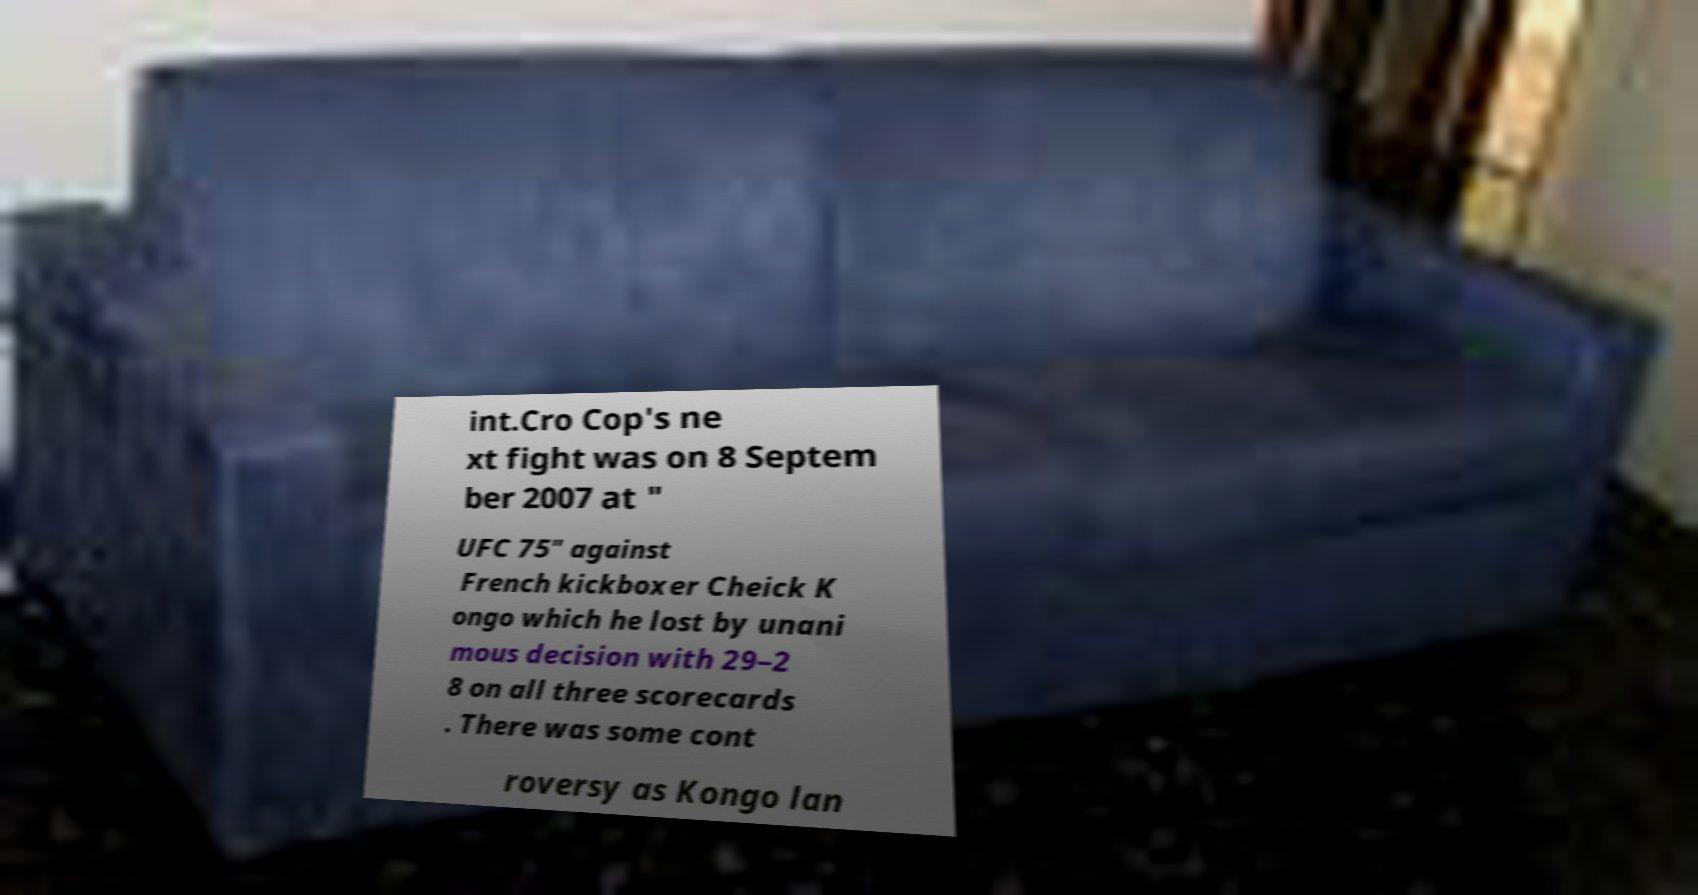Can you read and provide the text displayed in the image?This photo seems to have some interesting text. Can you extract and type it out for me? int.Cro Cop's ne xt fight was on 8 Septem ber 2007 at " UFC 75" against French kickboxer Cheick K ongo which he lost by unani mous decision with 29–2 8 on all three scorecards . There was some cont roversy as Kongo lan 